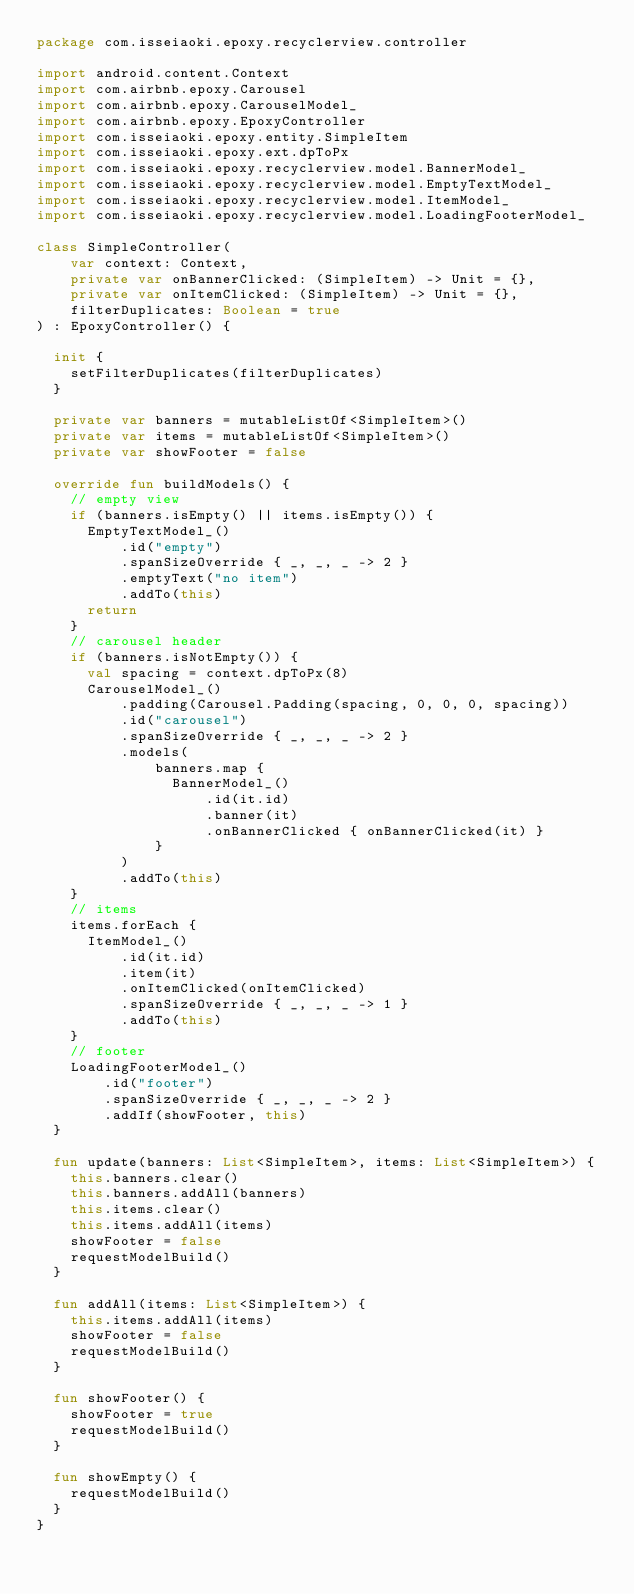<code> <loc_0><loc_0><loc_500><loc_500><_Kotlin_>package com.isseiaoki.epoxy.recyclerview.controller

import android.content.Context
import com.airbnb.epoxy.Carousel
import com.airbnb.epoxy.CarouselModel_
import com.airbnb.epoxy.EpoxyController
import com.isseiaoki.epoxy.entity.SimpleItem
import com.isseiaoki.epoxy.ext.dpToPx
import com.isseiaoki.epoxy.recyclerview.model.BannerModel_
import com.isseiaoki.epoxy.recyclerview.model.EmptyTextModel_
import com.isseiaoki.epoxy.recyclerview.model.ItemModel_
import com.isseiaoki.epoxy.recyclerview.model.LoadingFooterModel_

class SimpleController(
    var context: Context,
    private var onBannerClicked: (SimpleItem) -> Unit = {},
    private var onItemClicked: (SimpleItem) -> Unit = {},
    filterDuplicates: Boolean = true
) : EpoxyController() {

  init {
    setFilterDuplicates(filterDuplicates)
  }

  private var banners = mutableListOf<SimpleItem>()
  private var items = mutableListOf<SimpleItem>()
  private var showFooter = false

  override fun buildModels() {
    // empty view
    if (banners.isEmpty() || items.isEmpty()) {
      EmptyTextModel_()
          .id("empty")
          .spanSizeOverride { _, _, _ -> 2 }
          .emptyText("no item")
          .addTo(this)
      return
    }
    // carousel header
    if (banners.isNotEmpty()) {
      val spacing = context.dpToPx(8)
      CarouselModel_()
          .padding(Carousel.Padding(spacing, 0, 0, 0, spacing))
          .id("carousel")
          .spanSizeOverride { _, _, _ -> 2 }
          .models(
              banners.map {
                BannerModel_()
                    .id(it.id)
                    .banner(it)
                    .onBannerClicked { onBannerClicked(it) }
              }
          )
          .addTo(this)
    }
    // items
    items.forEach {
      ItemModel_()
          .id(it.id)
          .item(it)
          .onItemClicked(onItemClicked)
          .spanSizeOverride { _, _, _ -> 1 }
          .addTo(this)
    }
    // footer
    LoadingFooterModel_()
        .id("footer")
        .spanSizeOverride { _, _, _ -> 2 }
        .addIf(showFooter, this)
  }

  fun update(banners: List<SimpleItem>, items: List<SimpleItem>) {
    this.banners.clear()
    this.banners.addAll(banners)
    this.items.clear()
    this.items.addAll(items)
    showFooter = false
    requestModelBuild()
  }

  fun addAll(items: List<SimpleItem>) {
    this.items.addAll(items)
    showFooter = false
    requestModelBuild()
  }

  fun showFooter() {
    showFooter = true
    requestModelBuild()
  }

  fun showEmpty() {
    requestModelBuild()
  }
}</code> 